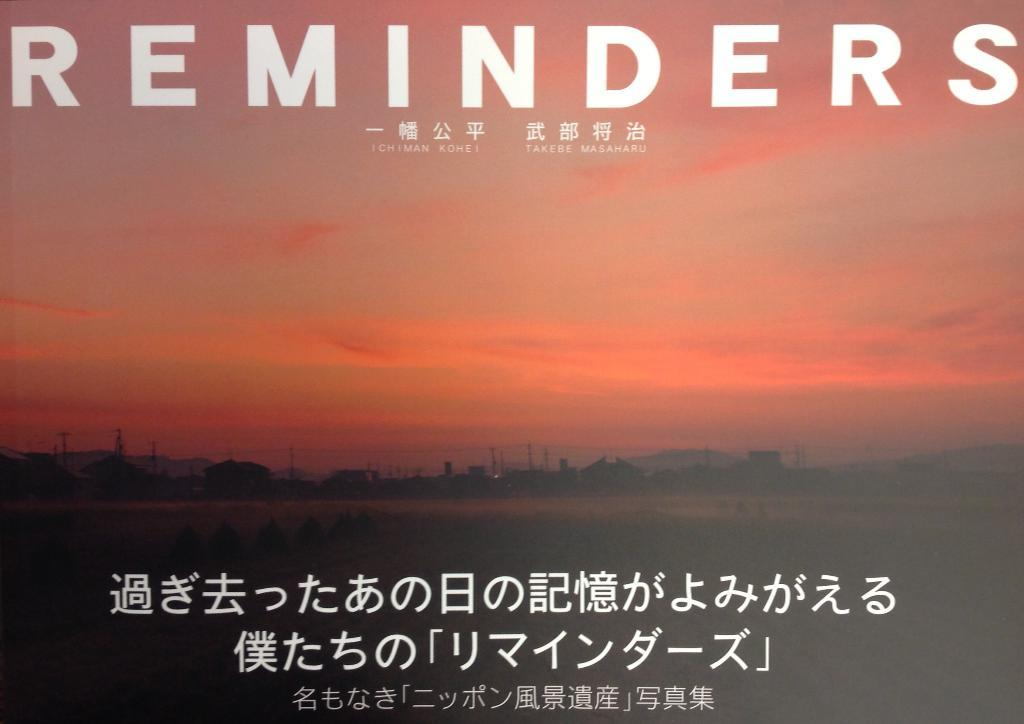<image>
Provide a brief description of the given image. A sign with Japanese letters and the word Reminders 